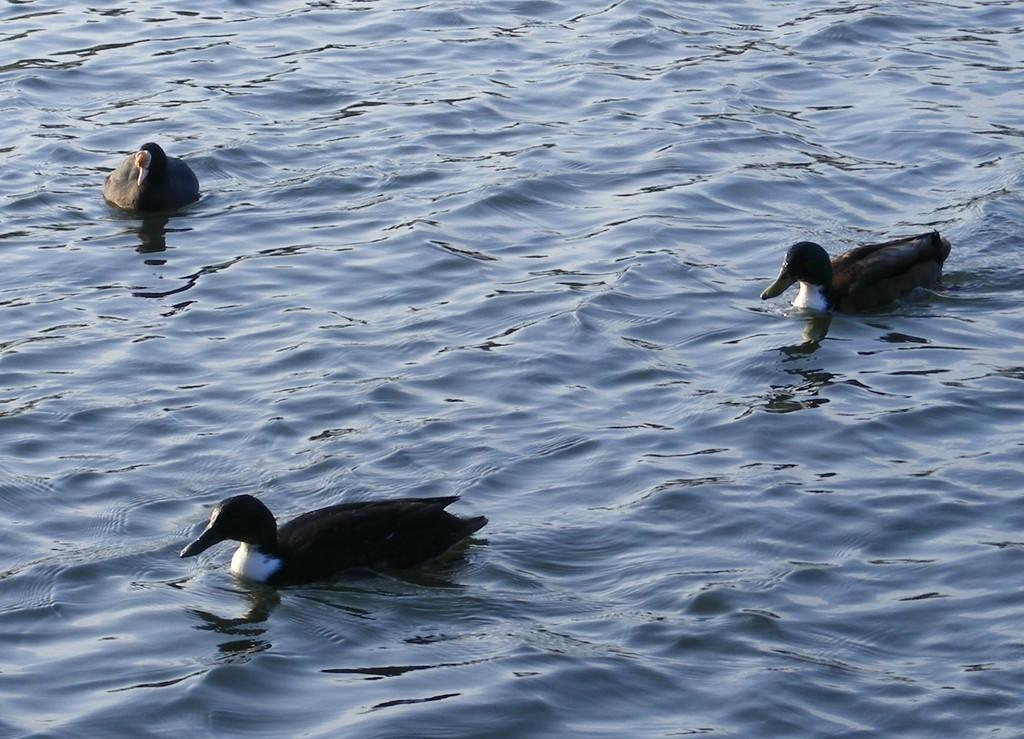What type of animals are in the image? There are three ducks in the image. Where are the ducks located? The ducks are in the water. How are the ducks positioned in the image? The ducks are in the center of the image. What type of tool is the ducks using for their breakfast in the image? There is no tool or reference to breakfast present in the image; the ducks are simply in the water. 